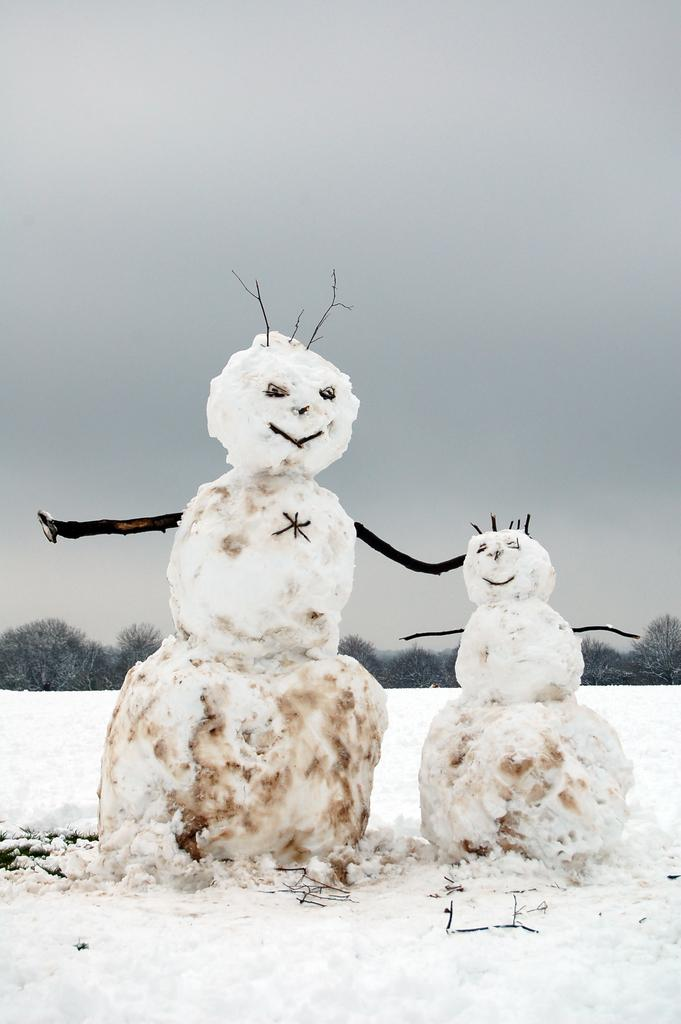How many snowmen are present in the image? There are two snowmen in the image. Where are the snowmen located? The snowmen are on the surface of the snow. What can be seen in the background of the image? There are trees and the sky visible in the background of the image. What type of throne is the snowman sitting on in the image? There is no throne present in the image; the snowmen are standing on the snow surface. 